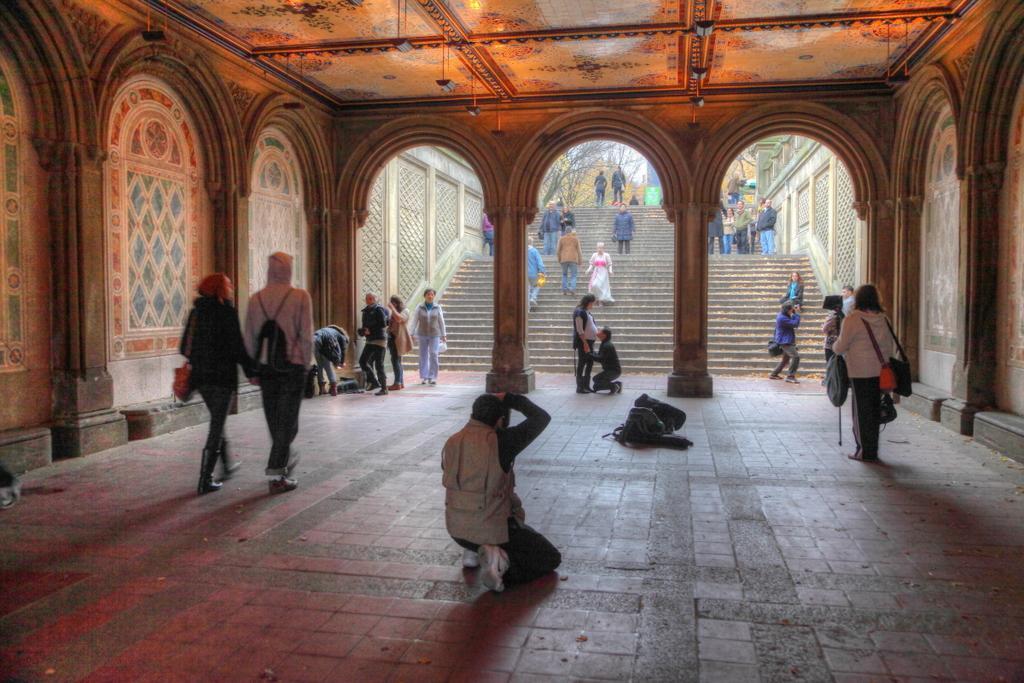Describe this image in one or two sentences. This image is clicked under the tunnel. In the middle there is a person who is taking the pictures with the camera. On the floor there are bags. In the background there are steps on which there are few people walking. On the left side there is a wall on which there is some design. At the top there is ceiling with the lights. On the right side there is a person standing on the floor by holding the bags. In front of the steps there are trees. 